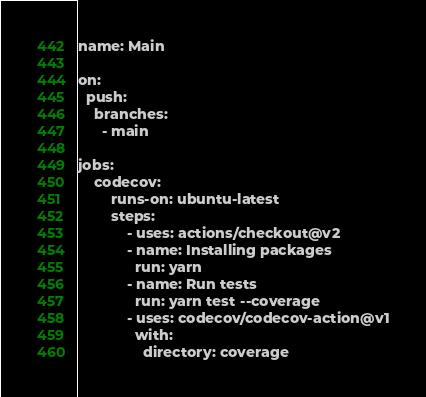<code> <loc_0><loc_0><loc_500><loc_500><_YAML_>name: Main

on:
  push:
    branches:
      - main

jobs:
    codecov:
        runs-on: ubuntu-latest
        steps:
            - uses: actions/checkout@v2
            - name: Installing packages
              run: yarn
            - name: Run tests
              run: yarn test --coverage
            - uses: codecov/codecov-action@v1
              with:
                directory: coverage</code> 